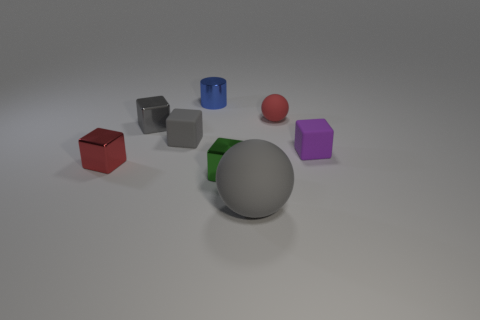Subtract all small purple rubber blocks. How many blocks are left? 4 Subtract all cylinders. How many objects are left? 7 Add 1 large gray objects. How many objects exist? 9 Subtract all red blocks. How many blocks are left? 4 Subtract 4 cubes. How many cubes are left? 1 Subtract all tiny shiny objects. Subtract all tiny blue cylinders. How many objects are left? 3 Add 5 big gray spheres. How many big gray spheres are left? 6 Add 3 rubber objects. How many rubber objects exist? 7 Subtract 1 red spheres. How many objects are left? 7 Subtract all cyan blocks. Subtract all yellow spheres. How many blocks are left? 5 